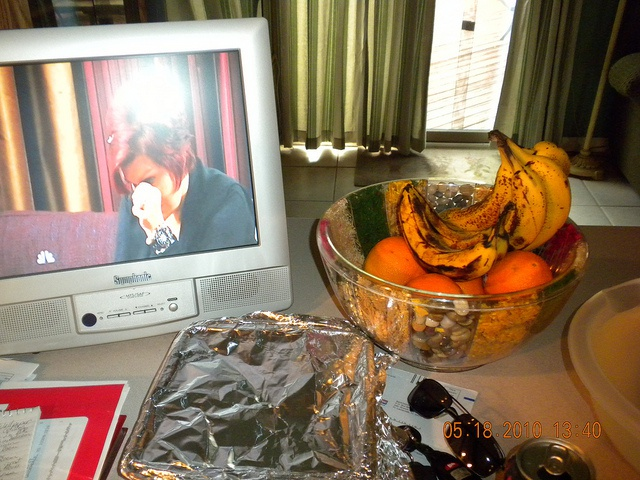Describe the objects in this image and their specific colors. I can see tv in maroon, white, darkgray, lightpink, and gray tones, bowl in maroon, brown, and red tones, people in maroon, gray, white, lightpink, and darkgray tones, bowl in maroon, brown, and black tones, and banana in maroon, red, and orange tones in this image. 